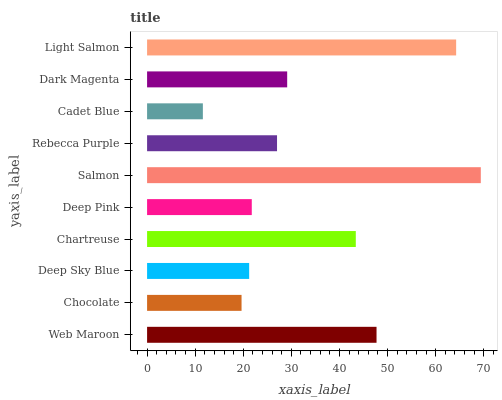Is Cadet Blue the minimum?
Answer yes or no. Yes. Is Salmon the maximum?
Answer yes or no. Yes. Is Chocolate the minimum?
Answer yes or no. No. Is Chocolate the maximum?
Answer yes or no. No. Is Web Maroon greater than Chocolate?
Answer yes or no. Yes. Is Chocolate less than Web Maroon?
Answer yes or no. Yes. Is Chocolate greater than Web Maroon?
Answer yes or no. No. Is Web Maroon less than Chocolate?
Answer yes or no. No. Is Dark Magenta the high median?
Answer yes or no. Yes. Is Rebecca Purple the low median?
Answer yes or no. Yes. Is Deep Pink the high median?
Answer yes or no. No. Is Deep Pink the low median?
Answer yes or no. No. 